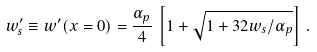Convert formula to latex. <formula><loc_0><loc_0><loc_500><loc_500>w ^ { \prime } _ { s } \equiv w ^ { \prime } ( x = 0 ) = \frac { \alpha _ { p } } { 4 } \, \left [ 1 + \sqrt { 1 + 3 2 w _ { s } / \alpha _ { p } } \right ] \, .</formula> 